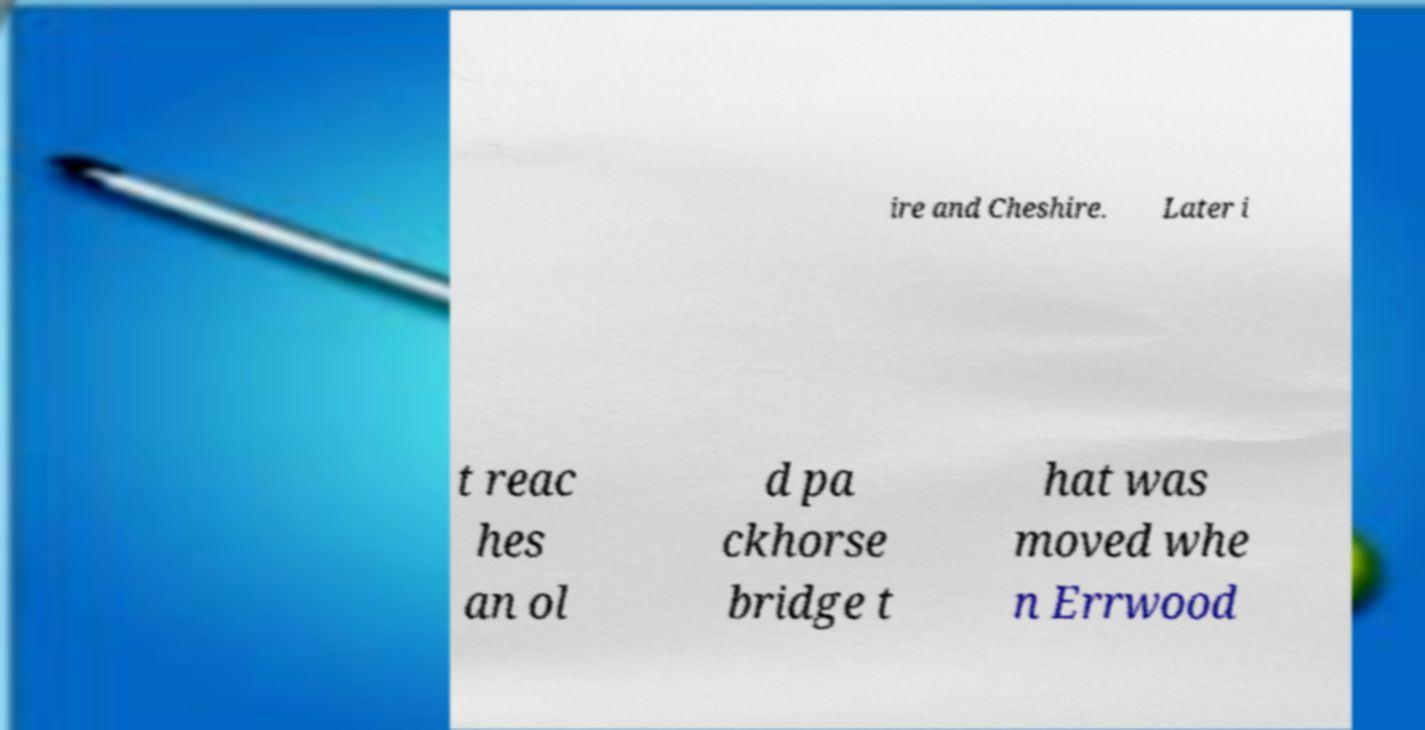I need the written content from this picture converted into text. Can you do that? ire and Cheshire. Later i t reac hes an ol d pa ckhorse bridge t hat was moved whe n Errwood 